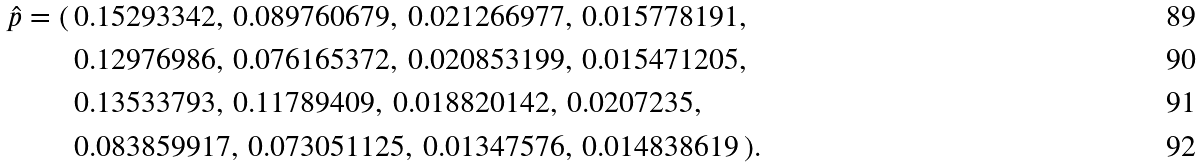<formula> <loc_0><loc_0><loc_500><loc_500>{ \hat { p } } = ( \, & 0 . 1 5 2 9 3 3 4 2 , \, 0 . 0 8 9 7 6 0 6 7 9 , \, 0 . 0 2 1 2 6 6 9 7 7 , \, 0 . 0 1 5 7 7 8 1 9 1 , \\ & 0 . 1 2 9 7 6 9 8 6 , \, 0 . 0 7 6 1 6 5 3 7 2 , \, 0 . 0 2 0 8 5 3 1 9 9 , \, 0 . 0 1 5 4 7 1 2 0 5 , \\ & 0 . 1 3 5 3 3 7 9 3 , \, 0 . 1 1 7 8 9 4 0 9 , \, 0 . 0 1 8 8 2 0 1 4 2 , \, 0 . 0 2 0 7 2 3 5 , \\ & 0 . 0 8 3 8 5 9 9 1 7 , \, 0 . 0 7 3 0 5 1 1 2 5 , \, 0 . 0 1 3 4 7 5 7 6 , \, 0 . 0 1 4 8 3 8 6 1 9 \, ) .</formula> 